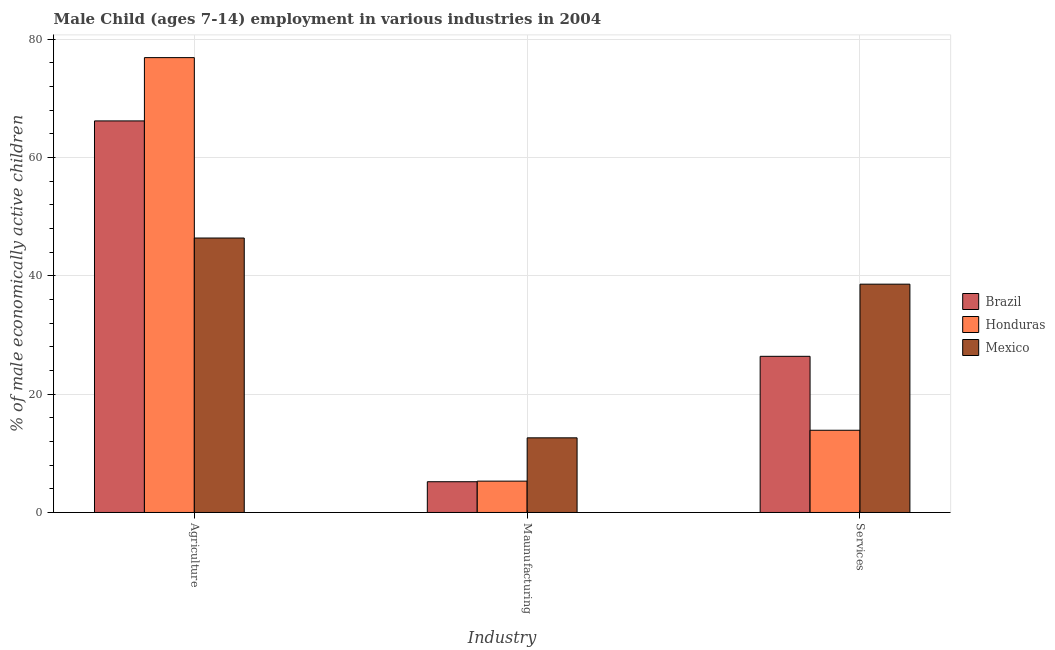How many different coloured bars are there?
Your answer should be very brief. 3. How many groups of bars are there?
Give a very brief answer. 3. Are the number of bars on each tick of the X-axis equal?
Ensure brevity in your answer.  Yes. What is the label of the 2nd group of bars from the left?
Provide a succinct answer. Maunufacturing. What is the percentage of economically active children in agriculture in Honduras?
Provide a short and direct response. 76.9. Across all countries, what is the maximum percentage of economically active children in services?
Keep it short and to the point. 38.6. In which country was the percentage of economically active children in manufacturing maximum?
Your response must be concise. Mexico. What is the total percentage of economically active children in agriculture in the graph?
Your answer should be compact. 189.5. What is the difference between the percentage of economically active children in agriculture in Mexico and that in Honduras?
Give a very brief answer. -30.5. What is the difference between the percentage of economically active children in services in Brazil and the percentage of economically active children in manufacturing in Honduras?
Your answer should be compact. 21.1. What is the average percentage of economically active children in services per country?
Your answer should be compact. 26.3. What is the difference between the percentage of economically active children in manufacturing and percentage of economically active children in agriculture in Honduras?
Ensure brevity in your answer.  -71.6. In how many countries, is the percentage of economically active children in services greater than 68 %?
Your answer should be very brief. 0. What is the ratio of the percentage of economically active children in services in Brazil to that in Honduras?
Offer a very short reply. 1.9. Is the percentage of economically active children in services in Brazil less than that in Mexico?
Your response must be concise. Yes. Is the difference between the percentage of economically active children in services in Honduras and Mexico greater than the difference between the percentage of economically active children in manufacturing in Honduras and Mexico?
Ensure brevity in your answer.  No. What is the difference between the highest and the second highest percentage of economically active children in manufacturing?
Ensure brevity in your answer.  7.32. What is the difference between the highest and the lowest percentage of economically active children in manufacturing?
Provide a succinct answer. 7.42. In how many countries, is the percentage of economically active children in agriculture greater than the average percentage of economically active children in agriculture taken over all countries?
Offer a terse response. 2. Is the sum of the percentage of economically active children in services in Honduras and Brazil greater than the maximum percentage of economically active children in manufacturing across all countries?
Provide a succinct answer. Yes. What does the 3rd bar from the right in Agriculture represents?
Your answer should be very brief. Brazil. Is it the case that in every country, the sum of the percentage of economically active children in agriculture and percentage of economically active children in manufacturing is greater than the percentage of economically active children in services?
Offer a very short reply. Yes. How many bars are there?
Your response must be concise. 9. Are all the bars in the graph horizontal?
Your answer should be compact. No. How many countries are there in the graph?
Give a very brief answer. 3. What is the difference between two consecutive major ticks on the Y-axis?
Keep it short and to the point. 20. Where does the legend appear in the graph?
Your answer should be very brief. Center right. What is the title of the graph?
Offer a terse response. Male Child (ages 7-14) employment in various industries in 2004. Does "Euro area" appear as one of the legend labels in the graph?
Your response must be concise. No. What is the label or title of the X-axis?
Keep it short and to the point. Industry. What is the label or title of the Y-axis?
Provide a succinct answer. % of male economically active children. What is the % of male economically active children of Brazil in Agriculture?
Make the answer very short. 66.2. What is the % of male economically active children in Honduras in Agriculture?
Give a very brief answer. 76.9. What is the % of male economically active children in Mexico in Agriculture?
Provide a short and direct response. 46.4. What is the % of male economically active children in Honduras in Maunufacturing?
Offer a terse response. 5.3. What is the % of male economically active children in Mexico in Maunufacturing?
Make the answer very short. 12.62. What is the % of male economically active children in Brazil in Services?
Give a very brief answer. 26.4. What is the % of male economically active children of Honduras in Services?
Make the answer very short. 13.9. What is the % of male economically active children in Mexico in Services?
Offer a very short reply. 38.6. Across all Industry, what is the maximum % of male economically active children in Brazil?
Provide a short and direct response. 66.2. Across all Industry, what is the maximum % of male economically active children of Honduras?
Provide a short and direct response. 76.9. Across all Industry, what is the maximum % of male economically active children of Mexico?
Provide a short and direct response. 46.4. Across all Industry, what is the minimum % of male economically active children in Mexico?
Your response must be concise. 12.62. What is the total % of male economically active children of Brazil in the graph?
Make the answer very short. 97.8. What is the total % of male economically active children in Honduras in the graph?
Provide a short and direct response. 96.1. What is the total % of male economically active children in Mexico in the graph?
Your answer should be compact. 97.62. What is the difference between the % of male economically active children in Honduras in Agriculture and that in Maunufacturing?
Give a very brief answer. 71.6. What is the difference between the % of male economically active children of Mexico in Agriculture and that in Maunufacturing?
Offer a very short reply. 33.78. What is the difference between the % of male economically active children of Brazil in Agriculture and that in Services?
Make the answer very short. 39.8. What is the difference between the % of male economically active children in Honduras in Agriculture and that in Services?
Offer a terse response. 63. What is the difference between the % of male economically active children in Brazil in Maunufacturing and that in Services?
Make the answer very short. -21.2. What is the difference between the % of male economically active children of Honduras in Maunufacturing and that in Services?
Your answer should be compact. -8.6. What is the difference between the % of male economically active children in Mexico in Maunufacturing and that in Services?
Your answer should be very brief. -25.98. What is the difference between the % of male economically active children of Brazil in Agriculture and the % of male economically active children of Honduras in Maunufacturing?
Provide a short and direct response. 60.9. What is the difference between the % of male economically active children in Brazil in Agriculture and the % of male economically active children in Mexico in Maunufacturing?
Offer a terse response. 53.58. What is the difference between the % of male economically active children in Honduras in Agriculture and the % of male economically active children in Mexico in Maunufacturing?
Provide a succinct answer. 64.28. What is the difference between the % of male economically active children of Brazil in Agriculture and the % of male economically active children of Honduras in Services?
Offer a terse response. 52.3. What is the difference between the % of male economically active children of Brazil in Agriculture and the % of male economically active children of Mexico in Services?
Make the answer very short. 27.6. What is the difference between the % of male economically active children of Honduras in Agriculture and the % of male economically active children of Mexico in Services?
Give a very brief answer. 38.3. What is the difference between the % of male economically active children of Brazil in Maunufacturing and the % of male economically active children of Mexico in Services?
Keep it short and to the point. -33.4. What is the difference between the % of male economically active children in Honduras in Maunufacturing and the % of male economically active children in Mexico in Services?
Your answer should be compact. -33.3. What is the average % of male economically active children in Brazil per Industry?
Your response must be concise. 32.6. What is the average % of male economically active children in Honduras per Industry?
Make the answer very short. 32.03. What is the average % of male economically active children of Mexico per Industry?
Keep it short and to the point. 32.54. What is the difference between the % of male economically active children in Brazil and % of male economically active children in Mexico in Agriculture?
Your answer should be very brief. 19.8. What is the difference between the % of male economically active children in Honduras and % of male economically active children in Mexico in Agriculture?
Your answer should be very brief. 30.5. What is the difference between the % of male economically active children of Brazil and % of male economically active children of Honduras in Maunufacturing?
Ensure brevity in your answer.  -0.1. What is the difference between the % of male economically active children in Brazil and % of male economically active children in Mexico in Maunufacturing?
Provide a short and direct response. -7.42. What is the difference between the % of male economically active children of Honduras and % of male economically active children of Mexico in Maunufacturing?
Ensure brevity in your answer.  -7.32. What is the difference between the % of male economically active children of Brazil and % of male economically active children of Mexico in Services?
Your response must be concise. -12.2. What is the difference between the % of male economically active children of Honduras and % of male economically active children of Mexico in Services?
Your response must be concise. -24.7. What is the ratio of the % of male economically active children in Brazil in Agriculture to that in Maunufacturing?
Give a very brief answer. 12.73. What is the ratio of the % of male economically active children of Honduras in Agriculture to that in Maunufacturing?
Ensure brevity in your answer.  14.51. What is the ratio of the % of male economically active children in Mexico in Agriculture to that in Maunufacturing?
Your response must be concise. 3.68. What is the ratio of the % of male economically active children of Brazil in Agriculture to that in Services?
Provide a succinct answer. 2.51. What is the ratio of the % of male economically active children of Honduras in Agriculture to that in Services?
Offer a very short reply. 5.53. What is the ratio of the % of male economically active children of Mexico in Agriculture to that in Services?
Keep it short and to the point. 1.2. What is the ratio of the % of male economically active children in Brazil in Maunufacturing to that in Services?
Your answer should be very brief. 0.2. What is the ratio of the % of male economically active children in Honduras in Maunufacturing to that in Services?
Your answer should be compact. 0.38. What is the ratio of the % of male economically active children of Mexico in Maunufacturing to that in Services?
Your answer should be compact. 0.33. What is the difference between the highest and the second highest % of male economically active children in Brazil?
Give a very brief answer. 39.8. What is the difference between the highest and the second highest % of male economically active children of Honduras?
Offer a terse response. 63. What is the difference between the highest and the second highest % of male economically active children in Mexico?
Provide a short and direct response. 7.8. What is the difference between the highest and the lowest % of male economically active children in Honduras?
Keep it short and to the point. 71.6. What is the difference between the highest and the lowest % of male economically active children in Mexico?
Provide a short and direct response. 33.78. 